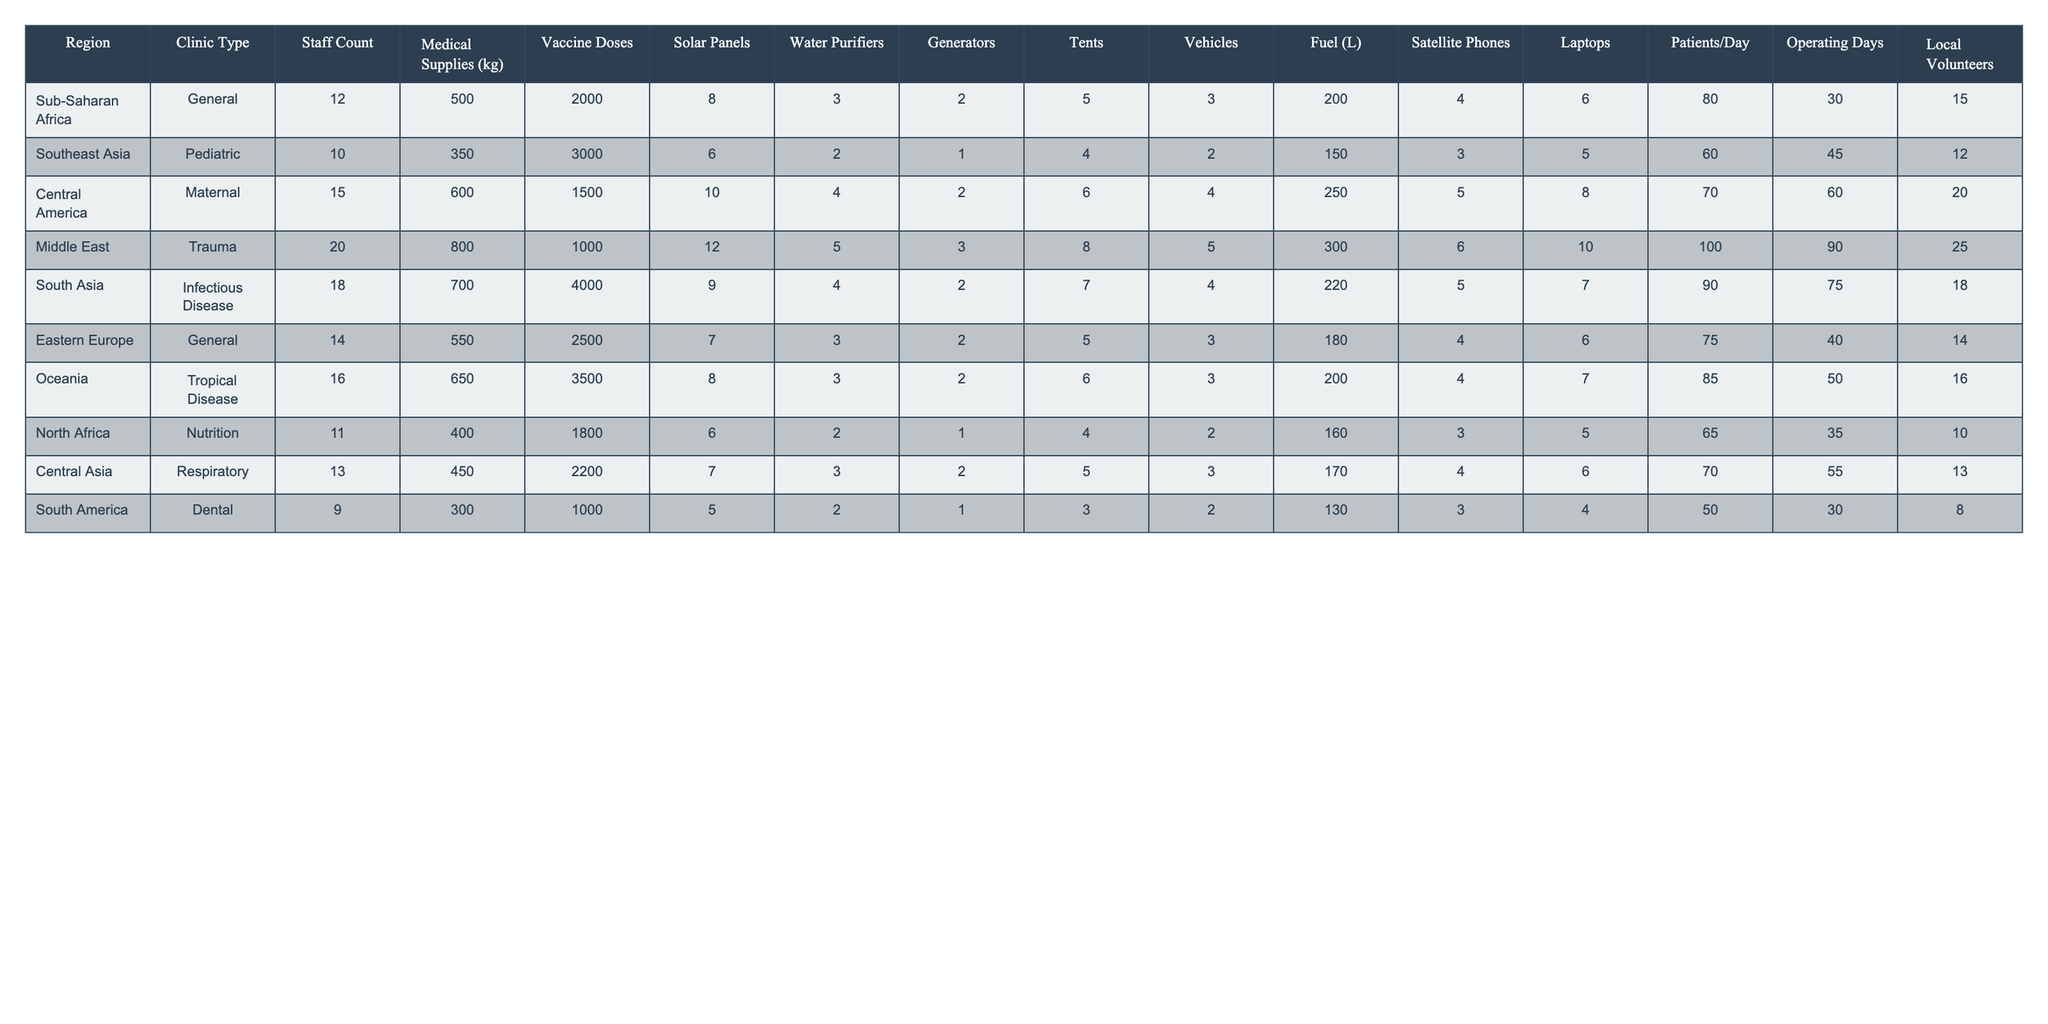What region has the highest staff count? The table shows that the Middle East has the highest staff count with 20 personnel.
Answer: Middle East How many medical supplies (in kg) does the tropical disease clinic in Oceania have? The table lists 650 kg of medical supplies for the tropical disease clinic in Oceania.
Answer: 650 kg Which clinic type has the lowest number of patients per day? By examining the Patients/Day column, the Dental clinic in South America has the lowest number with 50 patients per day.
Answer: Dental What is the average number of vaccine doses distributed across all clinics? To calculate the average of vaccine doses, sum all the doses (2000 + 3000 + 1500 + 1000 + 4000 + 2500 + 3500 + 1800 + 2200 + 1000) = 21000, then divide by the number of regions (10). Hence, the average is 21000 / 10 = 2100.
Answer: 2100 Does any clinic in Sub-Saharan Africa have more than 2000 vaccine doses? The General clinic in Sub-Saharan Africa has 2000 vaccine doses, which does not exceed 2000. Therefore, the answer is no.
Answer: No Which region has the lowest fuel consumption? By looking at the Fuel (L) column, the region with the lowest fuel consumption is South America, with only 2 liters of fuel.
Answer: South America What is the total number of local volunteers across all regions? To find the total local volunteers, sum all values in the Local Volunteers column (15 + 12 + 20 + 25 + 18 + 14 + 16 + 10 + 13 + 8) =  158.
Answer: 158 Which clinic type utilizes the most solar panels? The Trauma clinic in the Middle East uses the highest number of solar panels, totaling 12.
Answer: Trauma If we consider only the regions in Southeast Asia and South Asia, what is the total weight of medical supplies? For Southeast Asia, the weight is 350 kg, and for South Asia, it is 700 kg. Adding these gives a total of 350 + 700 = 1050 kg.
Answer: 1050 kg Which region has more tents, Sub-Saharan Africa or Central America? Sub-Saharan Africa has 5 tents and Central America has 6 tents. Since 6 is greater than 5, Central America has more.
Answer: Central America 